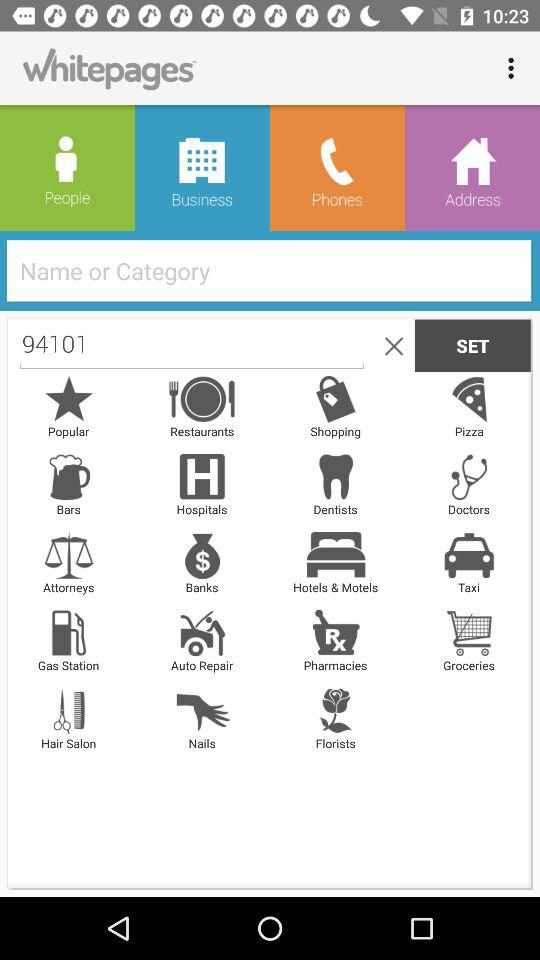What is the application name? The application name is "Whitepages". 